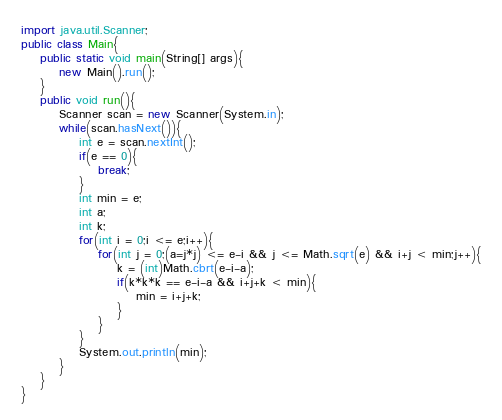<code> <loc_0><loc_0><loc_500><loc_500><_Java_>import java.util.Scanner;
public class Main{
	public static void main(String[] args){
		new Main().run();
	}
	public void run(){
		Scanner scan = new Scanner(System.in);
		while(scan.hasNext()){
			int e = scan.nextInt();
			if(e == 0){
				break;
			}
			int min = e;
			int a;
			int k;
			for(int i = 0;i <= e;i++){
				for(int j = 0;(a=j*j) <= e-i && j <= Math.sqrt(e) && i+j < min;j++){
					k = (int)Math.cbrt(e-i-a);
					if(k*k*k == e-i-a && i+j+k < min){
						min = i+j+k;
					}
				}
			}
			System.out.println(min);
		}
	}
}</code> 